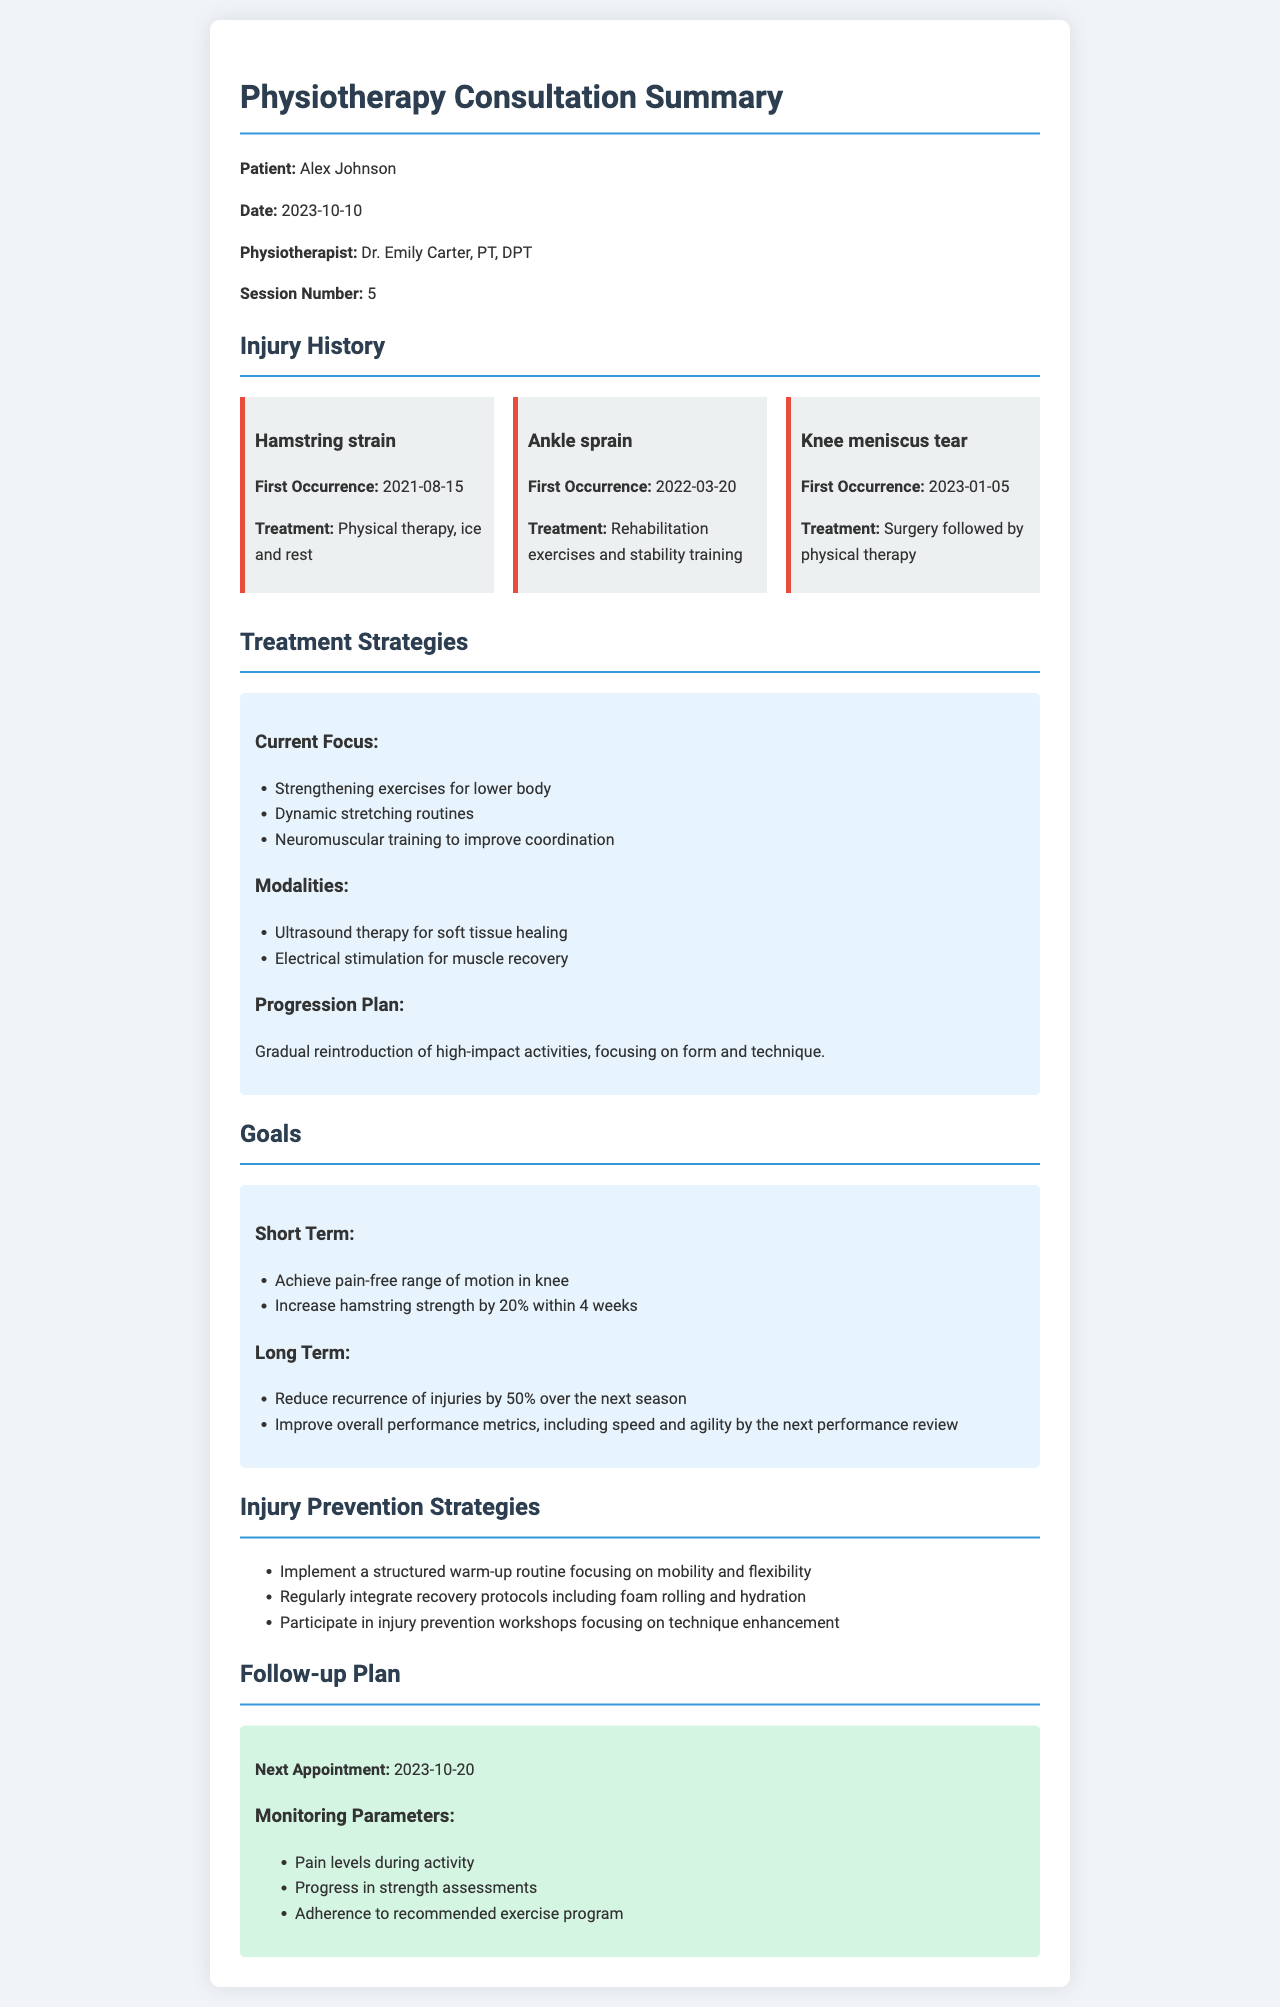What is the name of the patient? The document specifies the patient's name as Alex Johnson.
Answer: Alex Johnson When was the first occurrence of the knee meniscus tear? The document states the first occurrence date of the knee meniscus tear as 2023-01-05.
Answer: 2023-01-05 What treatment was given for the ankle sprain? The document describes the treatment for the ankle sprain as rehabilitation exercises and stability training.
Answer: Rehabilitation exercises and stability training What is the short-term goal for hamstring strength? The document mentions the short-term goal for hamstring strength as increasing it by 20% within 4 weeks.
Answer: Increase by 20% within 4 weeks What is the long-term goal mentioned for injury recurrence? The document states the long-term goal is to reduce recurrence of injuries by 50% over the next season.
Answer: Reduce by 50% over the next season What is one of the modalities used in treatment? The document lists ultrasound therapy as one of the modalities for treatment.
Answer: Ultrasound therapy What is the date of the next appointment? The document specifies the next appointment date as 2023-10-20.
Answer: 2023-10-20 What are the monitoring parameters mentioned in the follow-up plan? The document outlines monitoring parameters, which include pain levels during activity, progress in strength assessments, and adherence to the recommended exercise program.
Answer: Pain levels during activity, progress in strength assessments, adherence to the recommended exercise program What is the current focus of the treatment strategies? The document describes the current focus of treatment strategies as strengthening exercises for lower body, dynamic stretching routines, and neuromuscular training.
Answer: Strengthening exercises for lower body, dynamic stretching routines, neuromuscular training 